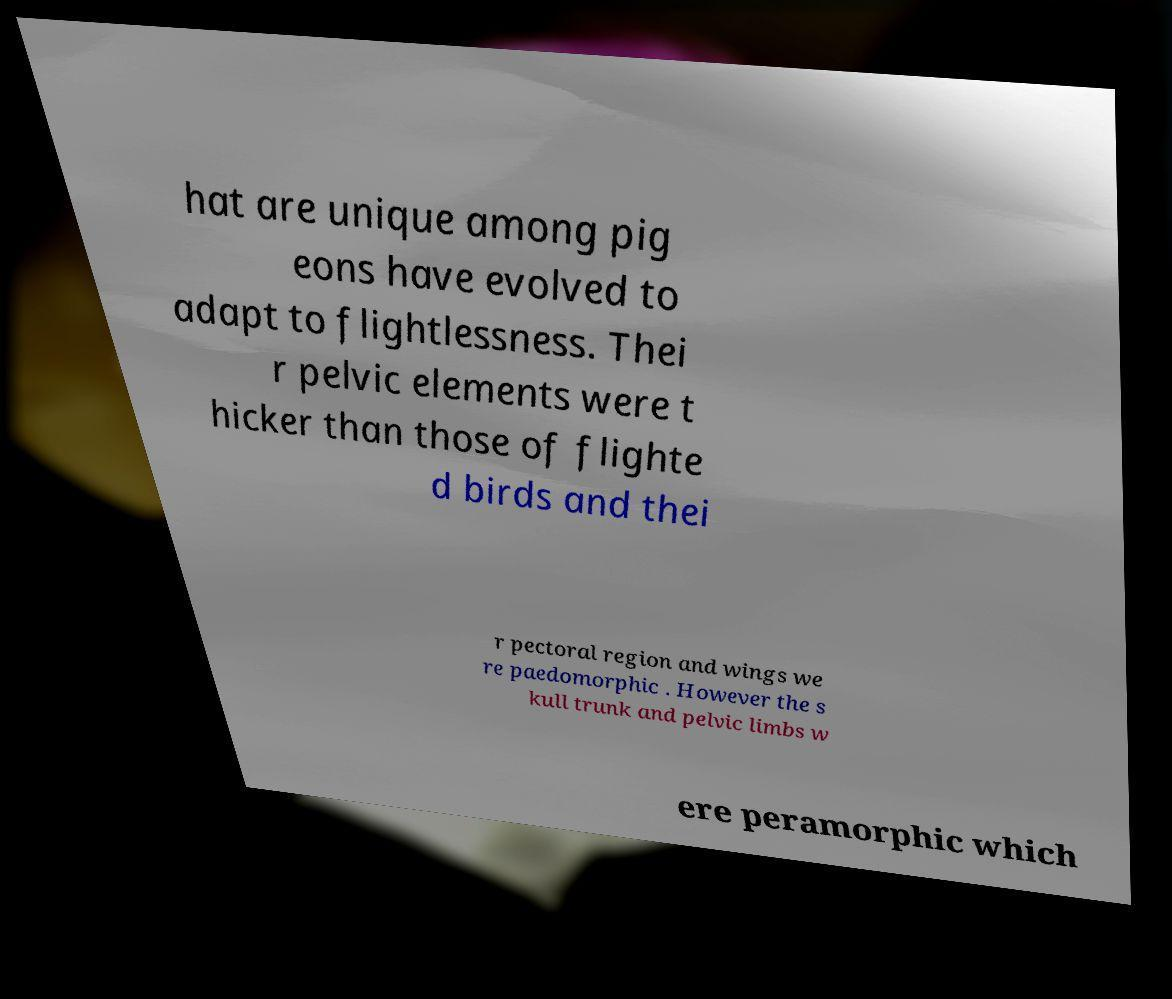For documentation purposes, I need the text within this image transcribed. Could you provide that? hat are unique among pig eons have evolved to adapt to flightlessness. Thei r pelvic elements were t hicker than those of flighte d birds and thei r pectoral region and wings we re paedomorphic . However the s kull trunk and pelvic limbs w ere peramorphic which 